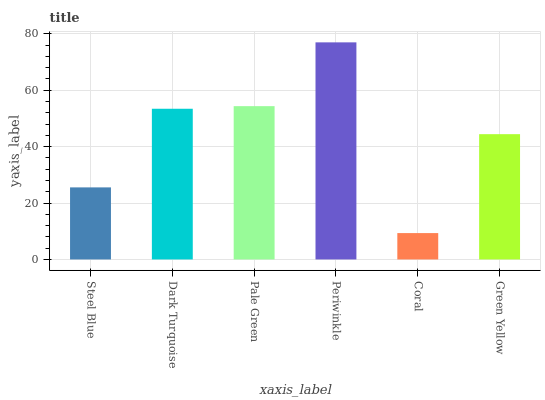Is Coral the minimum?
Answer yes or no. Yes. Is Periwinkle the maximum?
Answer yes or no. Yes. Is Dark Turquoise the minimum?
Answer yes or no. No. Is Dark Turquoise the maximum?
Answer yes or no. No. Is Dark Turquoise greater than Steel Blue?
Answer yes or no. Yes. Is Steel Blue less than Dark Turquoise?
Answer yes or no. Yes. Is Steel Blue greater than Dark Turquoise?
Answer yes or no. No. Is Dark Turquoise less than Steel Blue?
Answer yes or no. No. Is Dark Turquoise the high median?
Answer yes or no. Yes. Is Green Yellow the low median?
Answer yes or no. Yes. Is Periwinkle the high median?
Answer yes or no. No. Is Pale Green the low median?
Answer yes or no. No. 